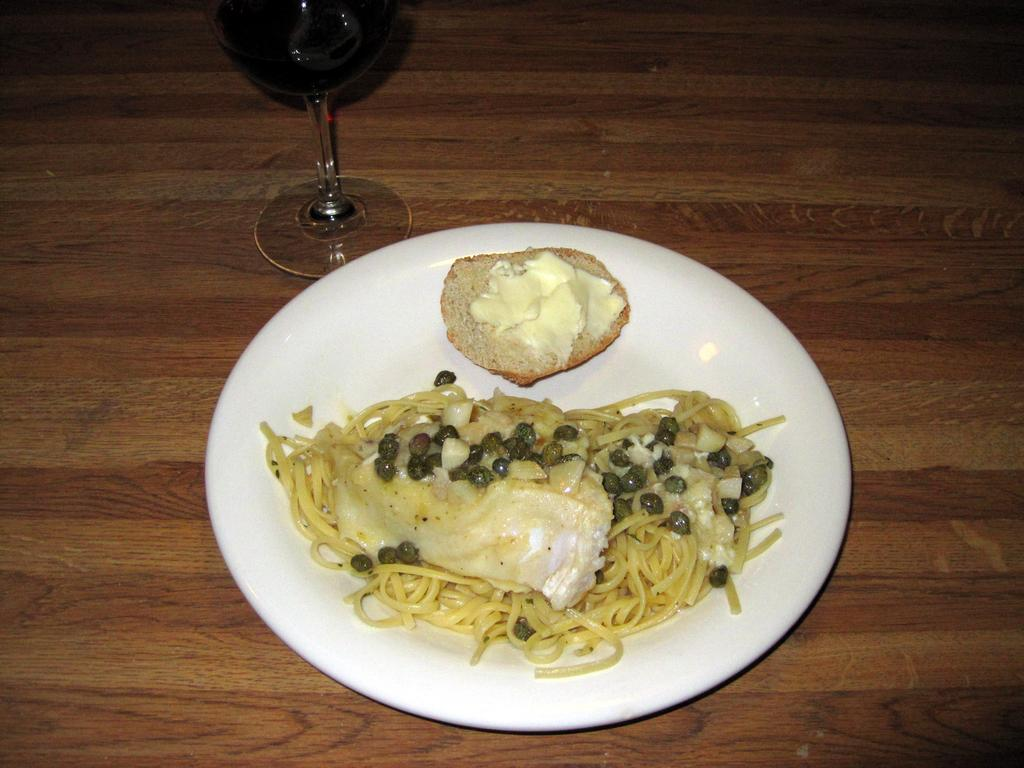What is on the plate in the image? There is a food item on a plate in the image. What beverage is visible in the image? There is a glass of wine in the image. What is the glass of wine placed on? The glass of wine is on a wooden platform. How many brothers are present in the image? There is no mention of brothers in the image, so we cannot determine their presence. 